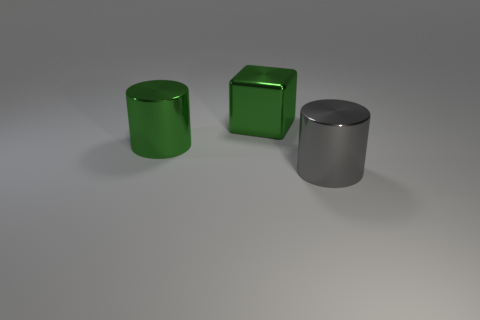Add 3 big green metal cylinders. How many objects exist? 6 Subtract all blocks. How many objects are left? 2 Subtract all big green objects. Subtract all large green metallic cylinders. How many objects are left? 0 Add 2 shiny objects. How many shiny objects are left? 5 Add 3 large green metallic blocks. How many large green metallic blocks exist? 4 Subtract 1 green blocks. How many objects are left? 2 